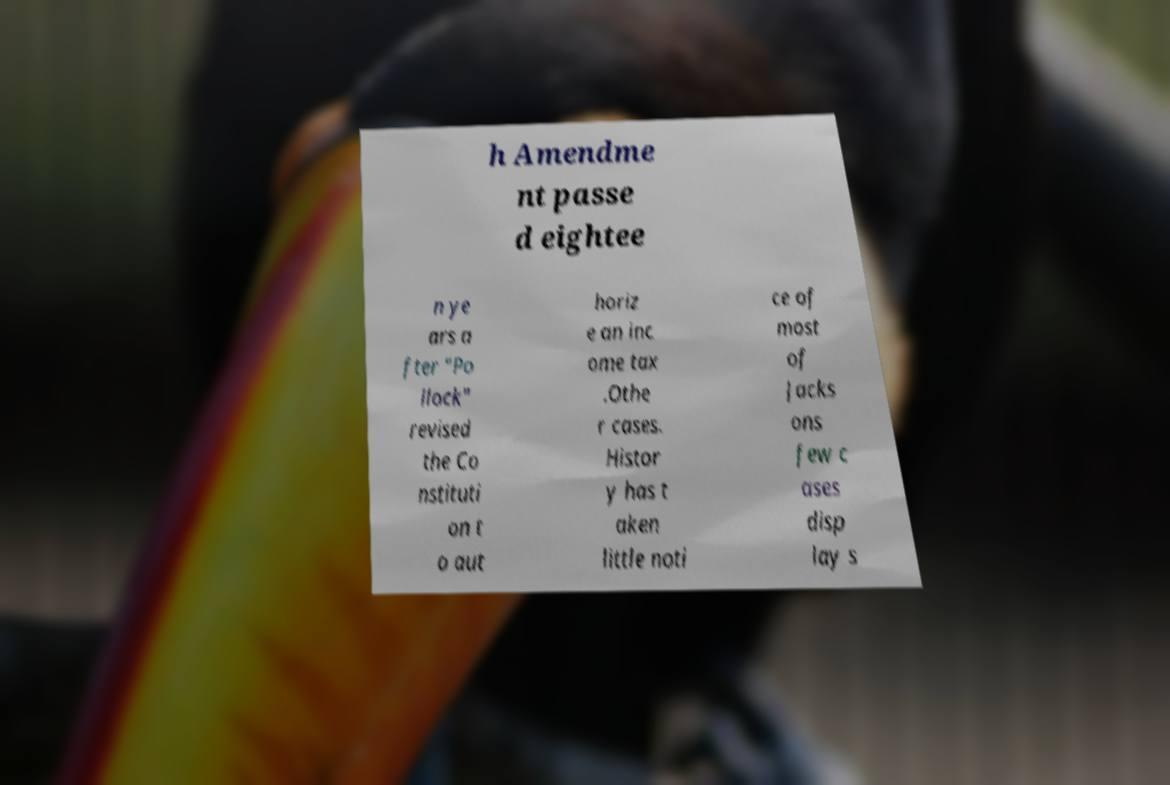Can you read and provide the text displayed in the image?This photo seems to have some interesting text. Can you extract and type it out for me? h Amendme nt passe d eightee n ye ars a fter "Po llock" revised the Co nstituti on t o aut horiz e an inc ome tax .Othe r cases. Histor y has t aken little noti ce of most of Jacks ons few c ases disp lay s 